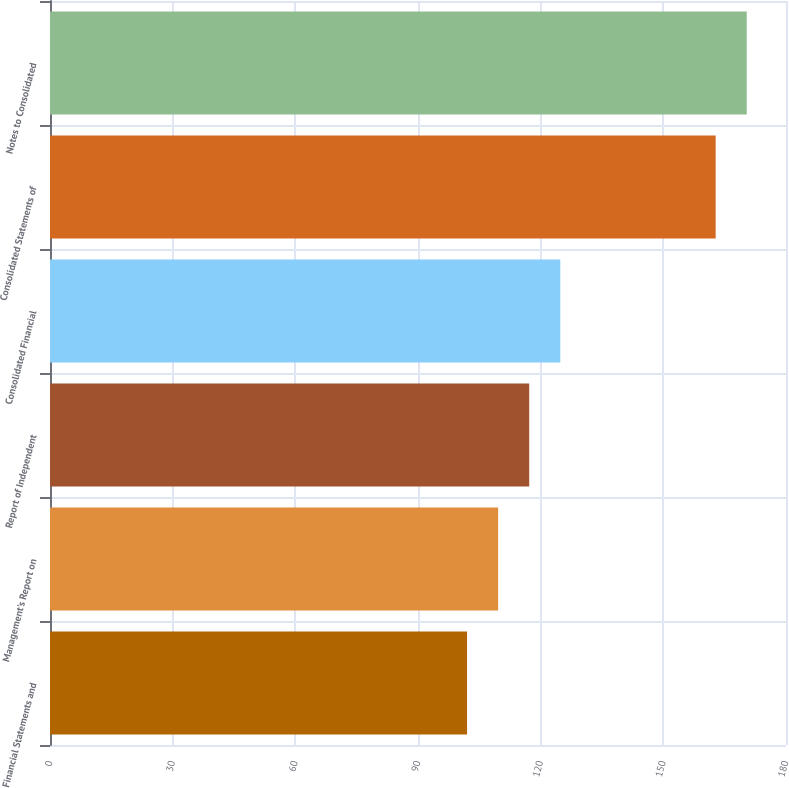Convert chart. <chart><loc_0><loc_0><loc_500><loc_500><bar_chart><fcel>Financial Statements and<fcel>Management's Report on<fcel>Report of Independent<fcel>Consolidated Financial<fcel>Consolidated Statements of<fcel>Notes to Consolidated<nl><fcel>102<fcel>109.6<fcel>117.2<fcel>124.8<fcel>162.8<fcel>170.4<nl></chart> 